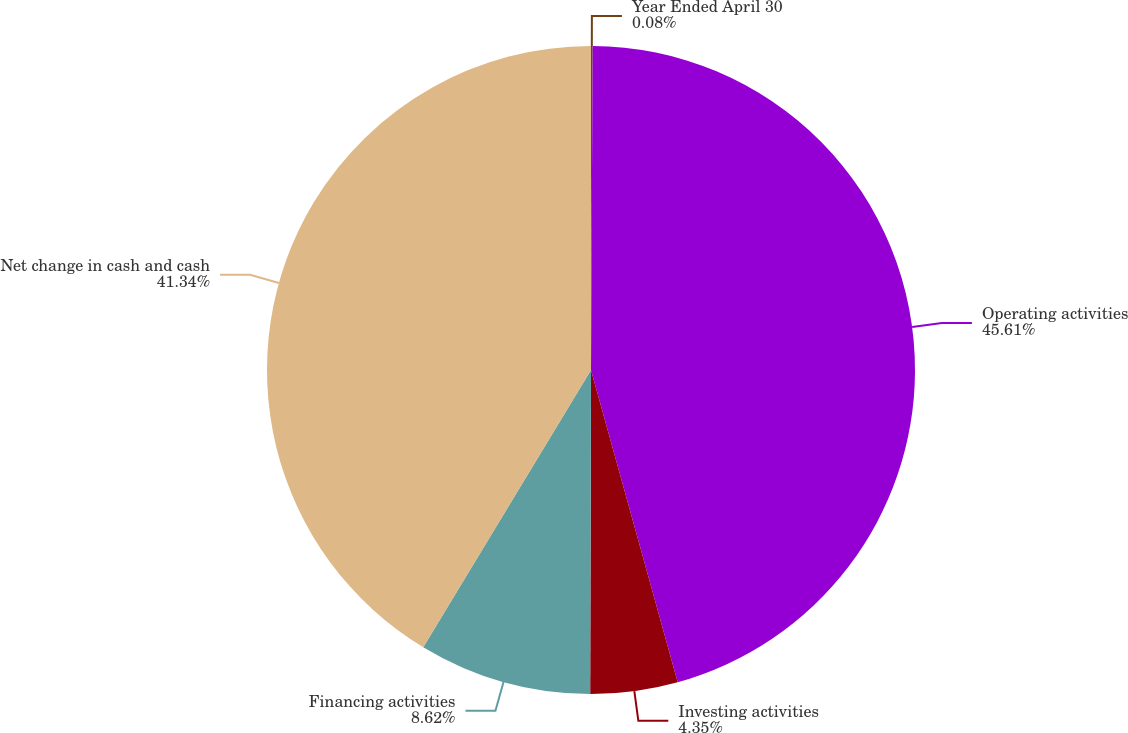<chart> <loc_0><loc_0><loc_500><loc_500><pie_chart><fcel>Year Ended April 30<fcel>Operating activities<fcel>Investing activities<fcel>Financing activities<fcel>Net change in cash and cash<nl><fcel>0.08%<fcel>45.6%<fcel>4.35%<fcel>8.62%<fcel>41.33%<nl></chart> 